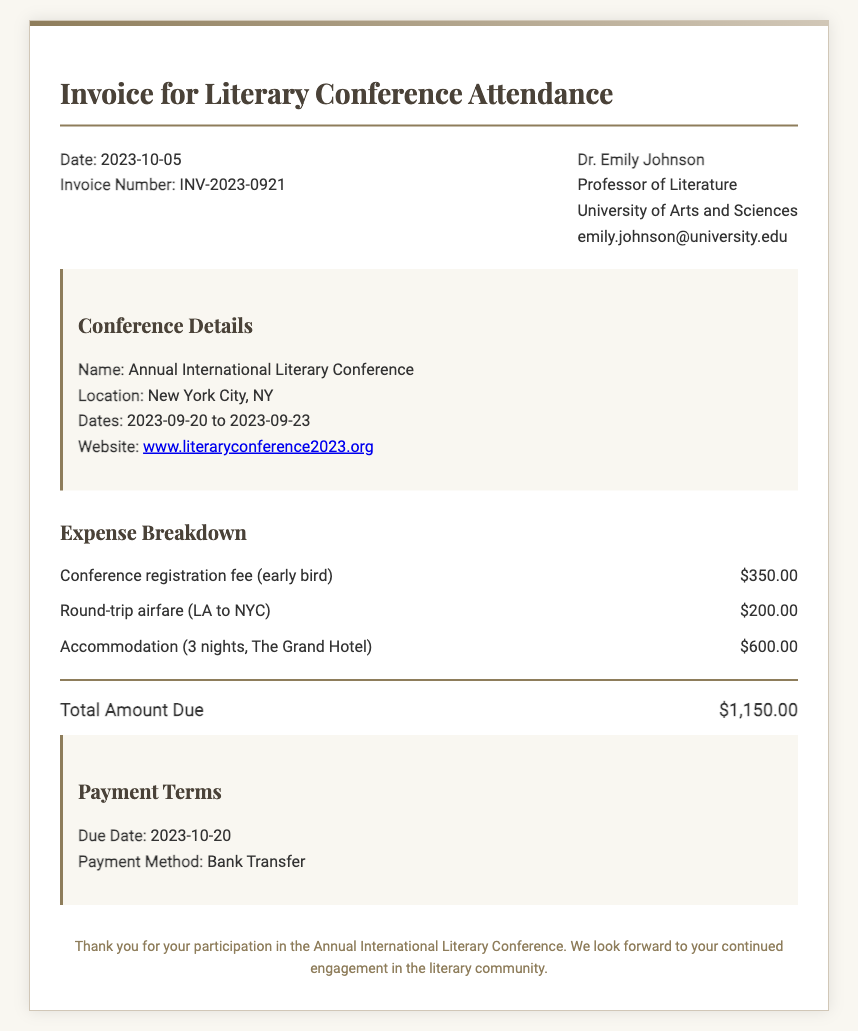What is the registration fee for the conference? The registration fee is listed in the expense breakdown section and is stated as $350.00.
Answer: $350.00 What are the accommodation costs? The accommodation costs for 3 nights at The Grand Hotel are detailed in the expense breakdown section, which totals $600.00.
Answer: $600.00 When is the invoice due date? The due date is specified in the payment terms section and is indicated as 2023-10-20.
Answer: 2023-10-20 Who is the invoice addressed to? The invoice is addressed to Dr. Emily Johnson, as mentioned at the top of the document.
Answer: Dr. Emily Johnson What is the total amount due? The total amount due is calculated at the bottom of the invoice and is given as $1,150.00.
Answer: $1,150.00 Which city hosted the literary conference? The location of the conference is listed as New York City, NY.
Answer: New York City, NY What is the payment method stated in the invoice? The payment method mentioned in the payment terms section is bank transfer.
Answer: Bank Transfer How many nights was accommodation booked for? The accommodation section specifies that 3 nights were booked at The Grand Hotel.
Answer: 3 nights What is the invoice number? The invoice number is provided in the header details section as INV-2023-0921.
Answer: INV-2023-0921 